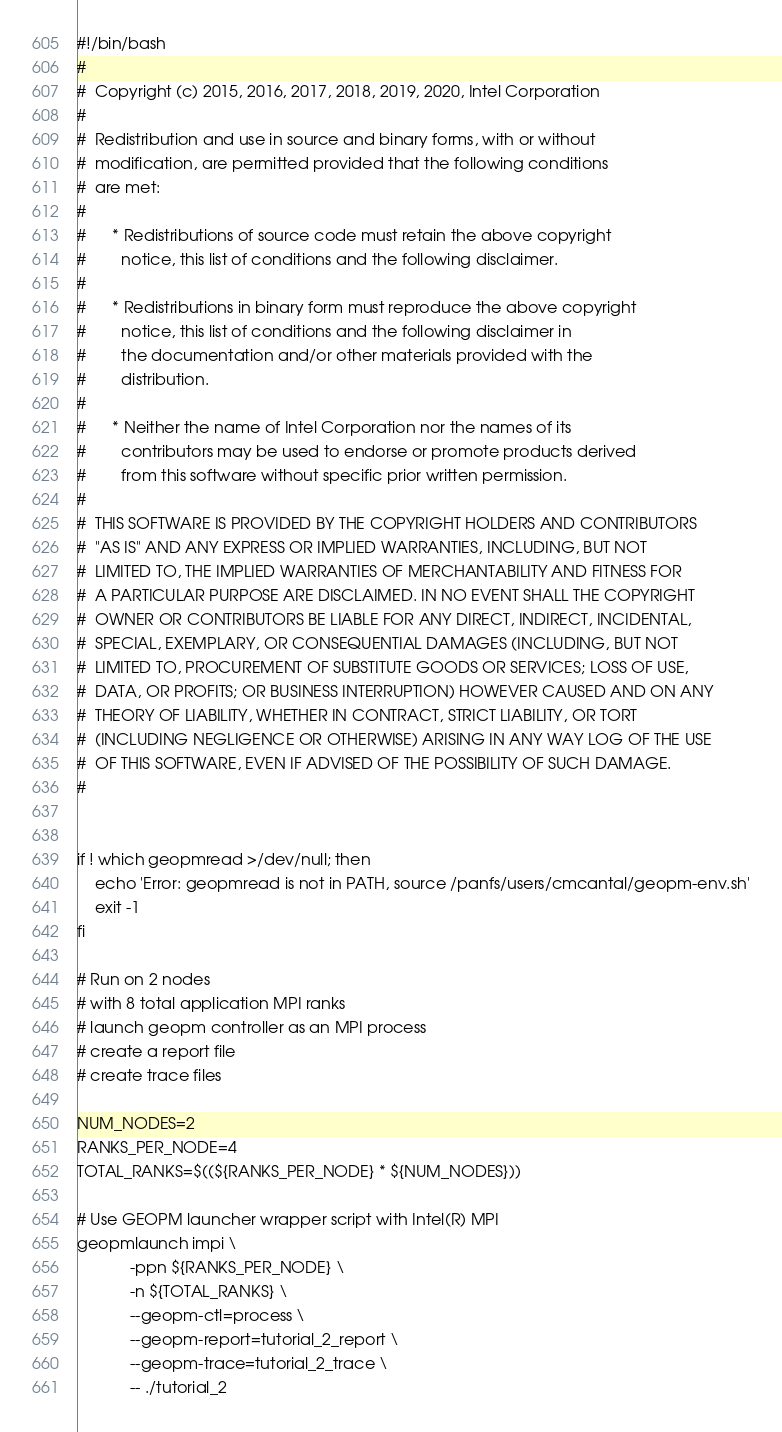Convert code to text. <code><loc_0><loc_0><loc_500><loc_500><_Bash_>#!/bin/bash
#
#  Copyright (c) 2015, 2016, 2017, 2018, 2019, 2020, Intel Corporation
#
#  Redistribution and use in source and binary forms, with or without
#  modification, are permitted provided that the following conditions
#  are met:
#
#      * Redistributions of source code must retain the above copyright
#        notice, this list of conditions and the following disclaimer.
#
#      * Redistributions in binary form must reproduce the above copyright
#        notice, this list of conditions and the following disclaimer in
#        the documentation and/or other materials provided with the
#        distribution.
#
#      * Neither the name of Intel Corporation nor the names of its
#        contributors may be used to endorse or promote products derived
#        from this software without specific prior written permission.
#
#  THIS SOFTWARE IS PROVIDED BY THE COPYRIGHT HOLDERS AND CONTRIBUTORS
#  "AS IS" AND ANY EXPRESS OR IMPLIED WARRANTIES, INCLUDING, BUT NOT
#  LIMITED TO, THE IMPLIED WARRANTIES OF MERCHANTABILITY AND FITNESS FOR
#  A PARTICULAR PURPOSE ARE DISCLAIMED. IN NO EVENT SHALL THE COPYRIGHT
#  OWNER OR CONTRIBUTORS BE LIABLE FOR ANY DIRECT, INDIRECT, INCIDENTAL,
#  SPECIAL, EXEMPLARY, OR CONSEQUENTIAL DAMAGES (INCLUDING, BUT NOT
#  LIMITED TO, PROCUREMENT OF SUBSTITUTE GOODS OR SERVICES; LOSS OF USE,
#  DATA, OR PROFITS; OR BUSINESS INTERRUPTION) HOWEVER CAUSED AND ON ANY
#  THEORY OF LIABILITY, WHETHER IN CONTRACT, STRICT LIABILITY, OR TORT
#  (INCLUDING NEGLIGENCE OR OTHERWISE) ARISING IN ANY WAY LOG OF THE USE
#  OF THIS SOFTWARE, EVEN IF ADVISED OF THE POSSIBILITY OF SUCH DAMAGE.
#


if ! which geopmread >/dev/null; then
    echo 'Error: geopmread is not in PATH, source /panfs/users/cmcantal/geopm-env.sh'
    exit -1
fi

# Run on 2 nodes
# with 8 total application MPI ranks
# launch geopm controller as an MPI process
# create a report file
# create trace files

NUM_NODES=2
RANKS_PER_NODE=4
TOTAL_RANKS=$((${RANKS_PER_NODE} * ${NUM_NODES}))

# Use GEOPM launcher wrapper script with Intel(R) MPI
geopmlaunch impi \
            -ppn ${RANKS_PER_NODE} \
            -n ${TOTAL_RANKS} \
            --geopm-ctl=process \
            --geopm-report=tutorial_2_report \
            --geopm-trace=tutorial_2_trace \
            -- ./tutorial_2
</code> 